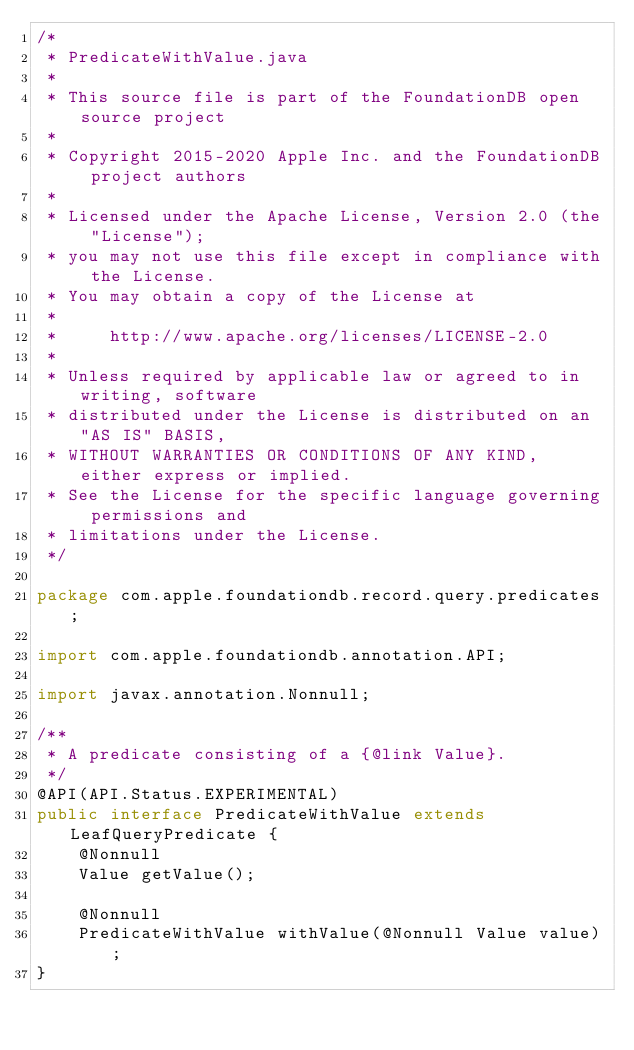Convert code to text. <code><loc_0><loc_0><loc_500><loc_500><_Java_>/*
 * PredicateWithValue.java
 *
 * This source file is part of the FoundationDB open source project
 *
 * Copyright 2015-2020 Apple Inc. and the FoundationDB project authors
 *
 * Licensed under the Apache License, Version 2.0 (the "License");
 * you may not use this file except in compliance with the License.
 * You may obtain a copy of the License at
 *
 *     http://www.apache.org/licenses/LICENSE-2.0
 *
 * Unless required by applicable law or agreed to in writing, software
 * distributed under the License is distributed on an "AS IS" BASIS,
 * WITHOUT WARRANTIES OR CONDITIONS OF ANY KIND, either express or implied.
 * See the License for the specific language governing permissions and
 * limitations under the License.
 */

package com.apple.foundationdb.record.query.predicates;

import com.apple.foundationdb.annotation.API;

import javax.annotation.Nonnull;

/**
 * A predicate consisting of a {@link Value}.
 */
@API(API.Status.EXPERIMENTAL)
public interface PredicateWithValue extends LeafQueryPredicate {
    @Nonnull
    Value getValue();

    @Nonnull
    PredicateWithValue withValue(@Nonnull Value value);
}
</code> 